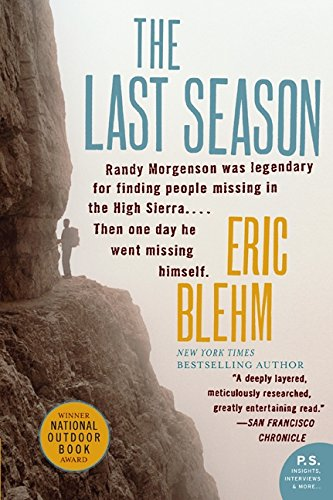Who wrote this book? The book 'The Last Season' was authored by Eric Blehm, a renowned writer known for his compelling narratives in non-fiction. 